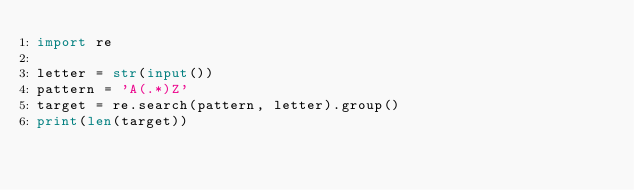<code> <loc_0><loc_0><loc_500><loc_500><_Python_>import re

letter = str(input())
pattern = 'A(.*)Z'
target = re.search(pattern, letter).group()
print(len(target))</code> 